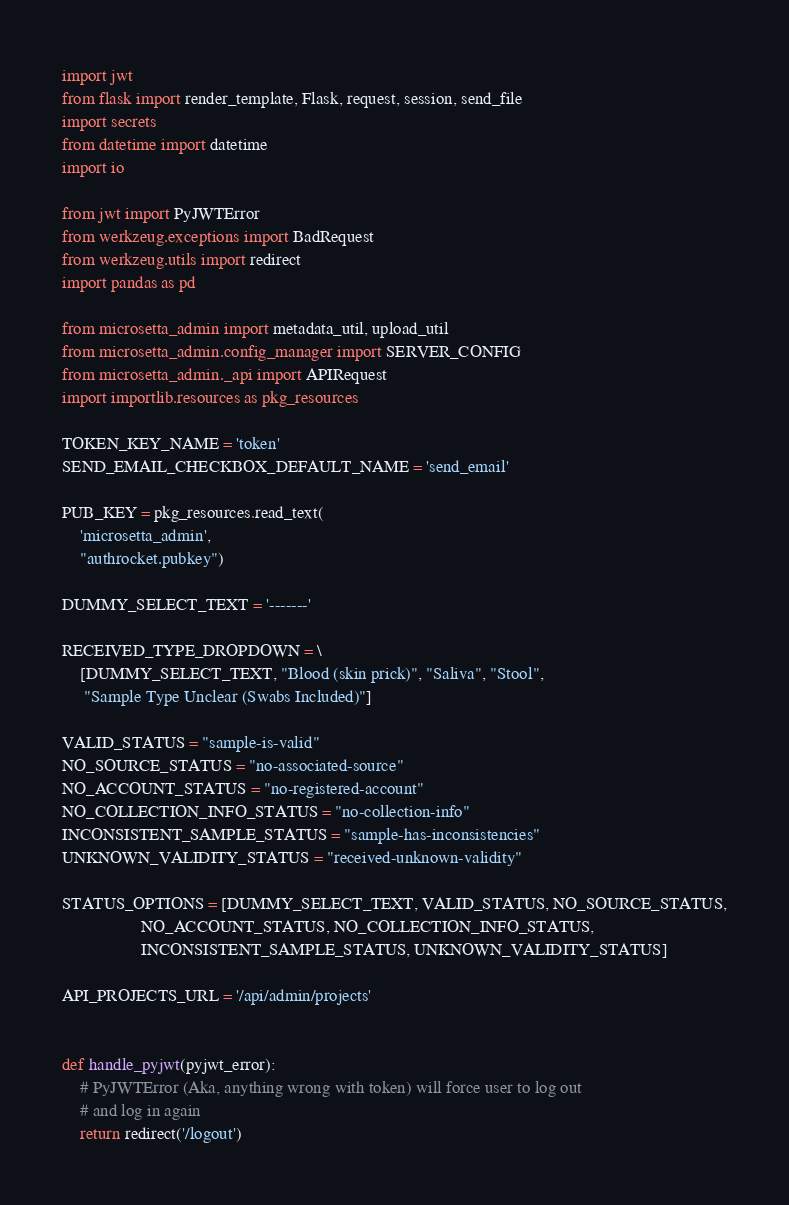Convert code to text. <code><loc_0><loc_0><loc_500><loc_500><_Python_>import jwt
from flask import render_template, Flask, request, session, send_file
import secrets
from datetime import datetime
import io

from jwt import PyJWTError
from werkzeug.exceptions import BadRequest
from werkzeug.utils import redirect
import pandas as pd

from microsetta_admin import metadata_util, upload_util
from microsetta_admin.config_manager import SERVER_CONFIG
from microsetta_admin._api import APIRequest
import importlib.resources as pkg_resources

TOKEN_KEY_NAME = 'token'
SEND_EMAIL_CHECKBOX_DEFAULT_NAME = 'send_email'

PUB_KEY = pkg_resources.read_text(
    'microsetta_admin',
    "authrocket.pubkey")

DUMMY_SELECT_TEXT = '-------'

RECEIVED_TYPE_DROPDOWN = \
    [DUMMY_SELECT_TEXT, "Blood (skin prick)", "Saliva", "Stool",
     "Sample Type Unclear (Swabs Included)"]

VALID_STATUS = "sample-is-valid"
NO_SOURCE_STATUS = "no-associated-source"
NO_ACCOUNT_STATUS = "no-registered-account"
NO_COLLECTION_INFO_STATUS = "no-collection-info"
INCONSISTENT_SAMPLE_STATUS = "sample-has-inconsistencies"
UNKNOWN_VALIDITY_STATUS = "received-unknown-validity"

STATUS_OPTIONS = [DUMMY_SELECT_TEXT, VALID_STATUS, NO_SOURCE_STATUS,
                  NO_ACCOUNT_STATUS, NO_COLLECTION_INFO_STATUS,
                  INCONSISTENT_SAMPLE_STATUS, UNKNOWN_VALIDITY_STATUS]

API_PROJECTS_URL = '/api/admin/projects'


def handle_pyjwt(pyjwt_error):
    # PyJWTError (Aka, anything wrong with token) will force user to log out
    # and log in again
    return redirect('/logout')

</code> 